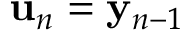Convert formula to latex. <formula><loc_0><loc_0><loc_500><loc_500>{ u } _ { n } = { y } _ { n - 1 }</formula> 